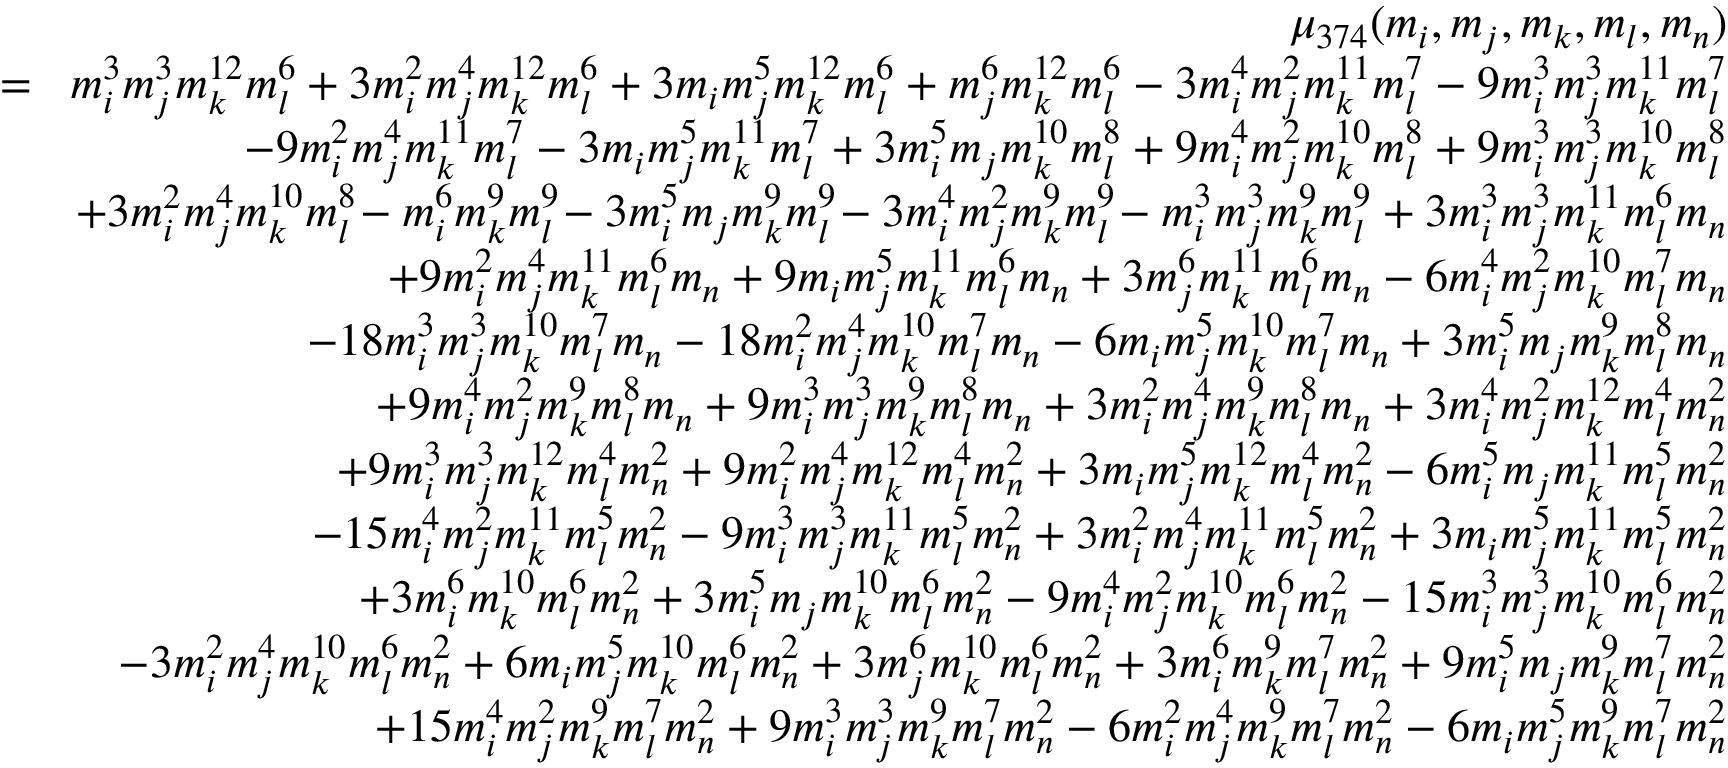<formula> <loc_0><loc_0><loc_500><loc_500>\begin{array} { r l r } & { \mu _ { 3 7 4 } ( m _ { i } , m _ { j } , m _ { k } , m _ { l } , m _ { n } ) } \\ & { \, = \, } & { m _ { i } ^ { 3 } m _ { j } ^ { 3 } m _ { k } ^ { 1 2 } m _ { l } ^ { 6 } + 3 m _ { i } ^ { 2 } m _ { j } ^ { 4 } m _ { k } ^ { 1 2 } m _ { l } ^ { 6 } + 3 m _ { i } m _ { j } ^ { 5 } m _ { k } ^ { 1 2 } m _ { l } ^ { 6 } + m _ { j } ^ { 6 } m _ { k } ^ { 1 2 } m _ { l } ^ { 6 } - 3 m _ { i } ^ { 4 } m _ { j } ^ { 2 } m _ { k } ^ { 1 1 } m _ { l } ^ { 7 } - 9 m _ { i } ^ { 3 } m _ { j } ^ { 3 } m _ { k } ^ { 1 1 } m _ { l } ^ { 7 } } \\ & { - 9 m _ { i } ^ { 2 } m _ { j } ^ { 4 } m _ { k } ^ { 1 1 } m _ { l } ^ { 7 } - 3 m _ { i } m _ { j } ^ { 5 } m _ { k } ^ { 1 1 } m _ { l } ^ { 7 } + 3 m _ { i } ^ { 5 } m _ { j } m _ { k } ^ { 1 0 } m _ { l } ^ { 8 } + 9 m _ { i } ^ { 4 } m _ { j } ^ { 2 } m _ { k } ^ { 1 0 } m _ { l } ^ { 8 } + 9 m _ { i } ^ { 3 } m _ { j } ^ { 3 } m _ { k } ^ { 1 0 } m _ { l } ^ { 8 } } \\ & { + 3 m _ { i } ^ { 2 } m _ { j } ^ { 4 } m _ { k } ^ { 1 0 } m _ { l } ^ { 8 } \, - m _ { i } ^ { 6 } m _ { k } ^ { 9 } m _ { l } ^ { 9 } \, - 3 m _ { i } ^ { 5 } m _ { j } m _ { k } ^ { 9 } m _ { l } ^ { 9 } \, - 3 m _ { i } ^ { 4 } m _ { j } ^ { 2 } m _ { k } ^ { 9 } m _ { l } ^ { 9 } \, - m _ { i } ^ { 3 } m _ { j } ^ { 3 } m _ { k } ^ { 9 } m _ { l } ^ { 9 } + 3 m _ { i } ^ { 3 } m _ { j } ^ { 3 } m _ { k } ^ { 1 1 } m _ { l } ^ { 6 } m _ { n } } \\ & { + 9 m _ { i } ^ { 2 } m _ { j } ^ { 4 } m _ { k } ^ { 1 1 } m _ { l } ^ { 6 } m _ { n } + 9 m _ { i } m _ { j } ^ { 5 } m _ { k } ^ { 1 1 } m _ { l } ^ { 6 } m _ { n } + 3 m _ { j } ^ { 6 } m _ { k } ^ { 1 1 } m _ { l } ^ { 6 } m _ { n } - 6 m _ { i } ^ { 4 } m _ { j } ^ { 2 } m _ { k } ^ { 1 0 } m _ { l } ^ { 7 } m _ { n } } \\ & { - 1 8 m _ { i } ^ { 3 } m _ { j } ^ { 3 } m _ { k } ^ { 1 0 } m _ { l } ^ { 7 } m _ { n } - 1 8 m _ { i } ^ { 2 } m _ { j } ^ { 4 } m _ { k } ^ { 1 0 } m _ { l } ^ { 7 } m _ { n } - 6 m _ { i } m _ { j } ^ { 5 } m _ { k } ^ { 1 0 } m _ { l } ^ { 7 } m _ { n } + 3 m _ { i } ^ { 5 } m _ { j } m _ { k } ^ { 9 } m _ { l } ^ { 8 } m _ { n } } \\ & { + 9 m _ { i } ^ { 4 } m _ { j } ^ { 2 } m _ { k } ^ { 9 } m _ { l } ^ { 8 } m _ { n } + 9 m _ { i } ^ { 3 } m _ { j } ^ { 3 } m _ { k } ^ { 9 } m _ { l } ^ { 8 } m _ { n } + 3 m _ { i } ^ { 2 } m _ { j } ^ { 4 } m _ { k } ^ { 9 } m _ { l } ^ { 8 } m _ { n } + 3 m _ { i } ^ { 4 } m _ { j } ^ { 2 } m _ { k } ^ { 1 2 } m _ { l } ^ { 4 } m _ { n } ^ { 2 } } \\ & { + 9 m _ { i } ^ { 3 } m _ { j } ^ { 3 } m _ { k } ^ { 1 2 } m _ { l } ^ { 4 } m _ { n } ^ { 2 } + 9 m _ { i } ^ { 2 } m _ { j } ^ { 4 } m _ { k } ^ { 1 2 } m _ { l } ^ { 4 } m _ { n } ^ { 2 } + 3 m _ { i } m _ { j } ^ { 5 } m _ { k } ^ { 1 2 } m _ { l } ^ { 4 } m _ { n } ^ { 2 } - 6 m _ { i } ^ { 5 } m _ { j } m _ { k } ^ { 1 1 } m _ { l } ^ { 5 } m _ { n } ^ { 2 } } \\ & { - 1 5 m _ { i } ^ { 4 } m _ { j } ^ { 2 } m _ { k } ^ { 1 1 } m _ { l } ^ { 5 } m _ { n } ^ { 2 } - 9 m _ { i } ^ { 3 } m _ { j } ^ { 3 } m _ { k } ^ { 1 1 } m _ { l } ^ { 5 } m _ { n } ^ { 2 } + 3 m _ { i } ^ { 2 } m _ { j } ^ { 4 } m _ { k } ^ { 1 1 } m _ { l } ^ { 5 } m _ { n } ^ { 2 } + 3 m _ { i } m _ { j } ^ { 5 } m _ { k } ^ { 1 1 } m _ { l } ^ { 5 } m _ { n } ^ { 2 } } \\ & { + 3 m _ { i } ^ { 6 } m _ { k } ^ { 1 0 } m _ { l } ^ { 6 } m _ { n } ^ { 2 } + 3 m _ { i } ^ { 5 } m _ { j } m _ { k } ^ { 1 0 } m _ { l } ^ { 6 } m _ { n } ^ { 2 } - 9 m _ { i } ^ { 4 } m _ { j } ^ { 2 } m _ { k } ^ { 1 0 } m _ { l } ^ { 6 } m _ { n } ^ { 2 } - 1 5 m _ { i } ^ { 3 } m _ { j } ^ { 3 } m _ { k } ^ { 1 0 } m _ { l } ^ { 6 } m _ { n } ^ { 2 } } \\ & { - 3 m _ { i } ^ { 2 } m _ { j } ^ { 4 } m _ { k } ^ { 1 0 } m _ { l } ^ { 6 } m _ { n } ^ { 2 } + 6 m _ { i } m _ { j } ^ { 5 } m _ { k } ^ { 1 0 } m _ { l } ^ { 6 } m _ { n } ^ { 2 } + 3 m _ { j } ^ { 6 } m _ { k } ^ { 1 0 } m _ { l } ^ { 6 } m _ { n } ^ { 2 } + 3 m _ { i } ^ { 6 } m _ { k } ^ { 9 } m _ { l } ^ { 7 } m _ { n } ^ { 2 } + 9 m _ { i } ^ { 5 } m _ { j } m _ { k } ^ { 9 } m _ { l } ^ { 7 } m _ { n } ^ { 2 } } \\ & { + 1 5 m _ { i } ^ { 4 } m _ { j } ^ { 2 } m _ { k } ^ { 9 } m _ { l } ^ { 7 } m _ { n } ^ { 2 } + 9 m _ { i } ^ { 3 } m _ { j } ^ { 3 } m _ { k } ^ { 9 } m _ { l } ^ { 7 } m _ { n } ^ { 2 } - 6 m _ { i } ^ { 2 } m _ { j } ^ { 4 } m _ { k } ^ { 9 } m _ { l } ^ { 7 } m _ { n } ^ { 2 } - 6 m _ { i } m _ { j } ^ { 5 } m _ { k } ^ { 9 } m _ { l } ^ { 7 } m _ { n } ^ { 2 } } \end{array}</formula> 